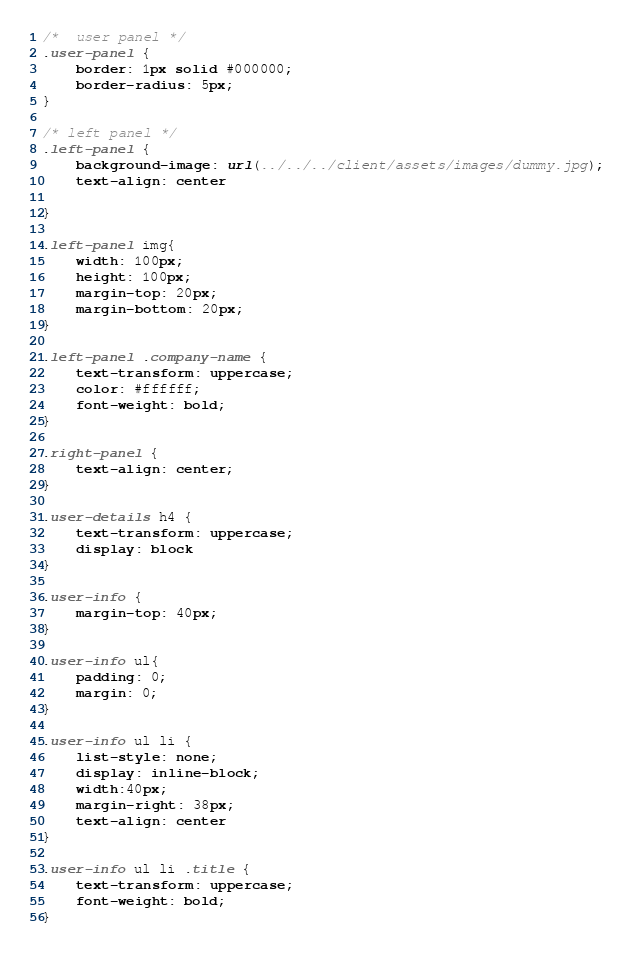Convert code to text. <code><loc_0><loc_0><loc_500><loc_500><_CSS_>/*  user panel */
.user-panel {
    border: 1px solid #000000;
    border-radius: 5px;
}

/* left panel */
.left-panel {
    background-image: url(../../../client/assets/images/dummy.jpg);
    text-align: center
    
}

.left-panel img{
    width: 100px;
    height: 100px;
    margin-top: 20px;
    margin-bottom: 20px;
}

.left-panel .company-name {
    text-transform: uppercase;
    color: #ffffff;
    font-weight: bold;
}

.right-panel {
    text-align: center;
}

.user-details h4 {
    text-transform: uppercase;
    display: block
}

.user-info {
    margin-top: 40px;
}

.user-info ul{
    padding: 0;
    margin: 0;
}

.user-info ul li {
    list-style: none;
    display: inline-block;
    width:40px;
    margin-right: 38px;
    text-align: center
}

.user-info ul li .title {
    text-transform: uppercase;
    font-weight: bold;
}</code> 